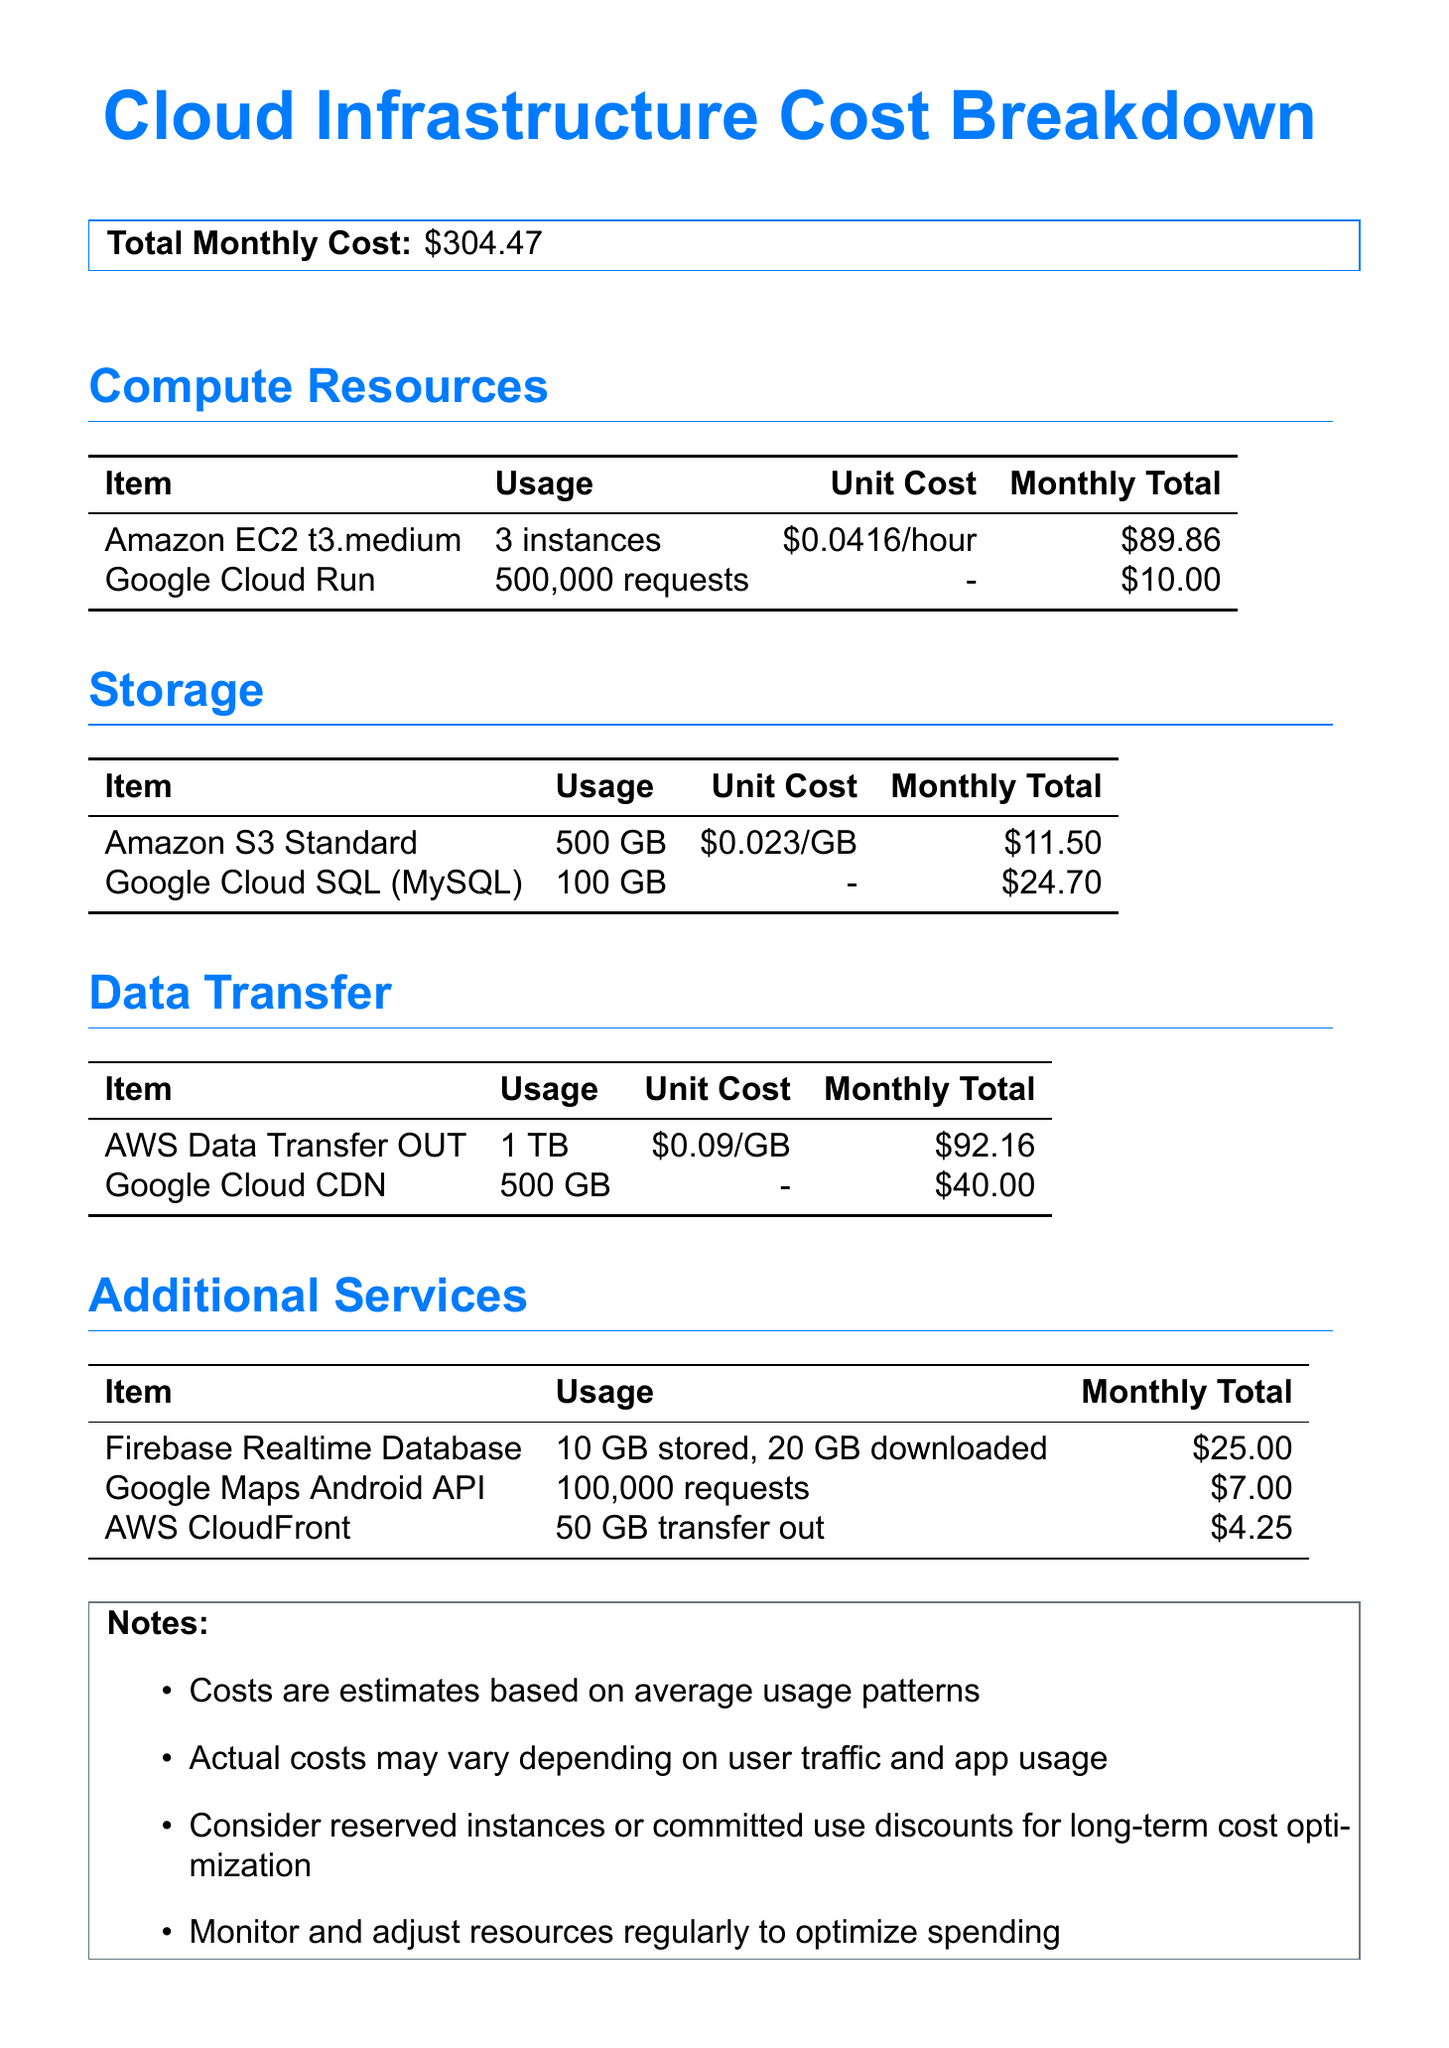What is the total monthly cost? The total monthly cost is presented in the document, which is \$304.47.
Answer: \$304.47 How many Amazon EC2 instances are used? The document specifies that there are 3 Amazon EC2 t3.medium instances used for compute resources.
Answer: 3 What is the monthly total for Google Cloud SQL? The monthly total for Google Cloud SQL is clearly stated in the document.
Answer: \$24.70 What is the unit cost for AWS Data Transfer OUT? The document provides the unit cost for AWS Data Transfer OUT as \$0.09 per GB.
Answer: \$0.09 What service incurs a fee of \$10.00 for 500,000 requests? The document indicates that Google Cloud Run incurs a monthly fee of \$10.00 for 500,000 requests.
Answer: Google Cloud Run How much is spent on Firebase Realtime Database? The document outlines the monthly total for Firebase Realtime Database as \$25.00.
Answer: \$25.00 Which category has the highest total monthly cost? The document allows for comparison across categories, with Data Transfer having the highest total monthly cost of \$132.16.
Answer: Data Transfer What is one suggestion mentioned for cost optimization? The notes section of the document mentions considering reserved instances or committed use discounts for long-term cost optimization.
Answer: Reserved instances What is the usage for Google Maps Android API? The document specifies that the usage for Google Maps Android API is 100,000 requests.
Answer: 100,000 requests 